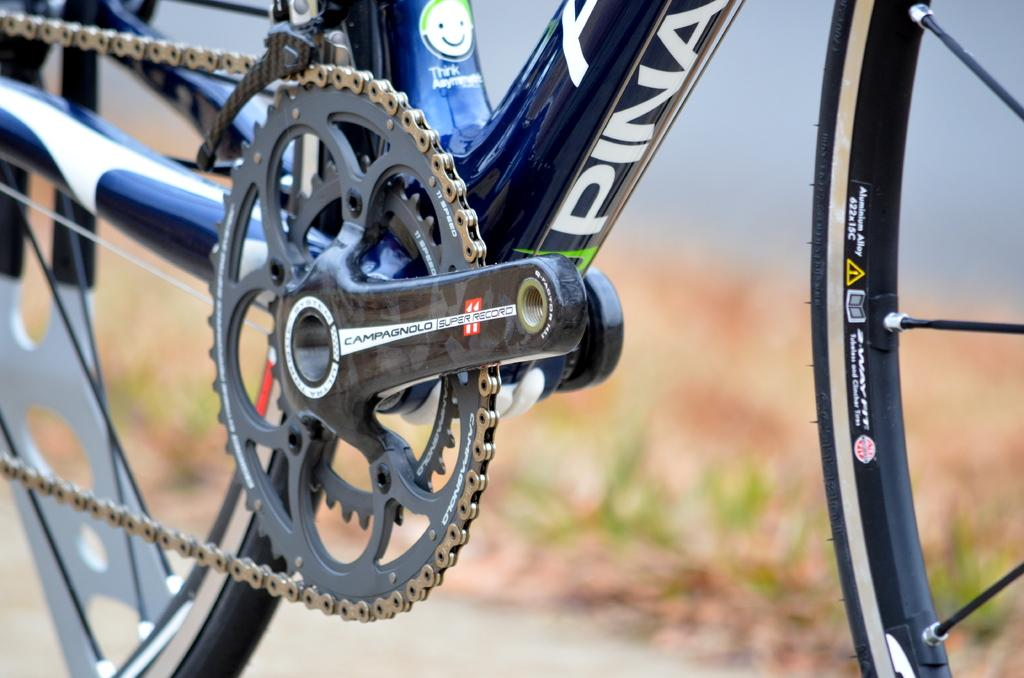What is the main object in the image? There is a bicycle in the image. What colors can be seen on the bicycle? The bicycle is white and blue. Is there any text or name on the bicycle? Yes, the name is written on the bicycle. What type of terrain is visible in the image? There is grass visible in the image. What part of the natural environment can be seen in the image? The sky is visible in the image, but it is blurry. How many dolls are sitting on the bicycle in the image? There are no dolls present in the image; it features a bicycle with a name written on it. What type of grain is growing in the background of the image? There is no grain visible in the image; it features a bicycle and grass in the background. 